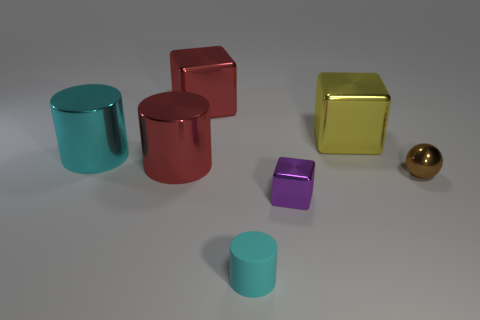How many other objects are there of the same color as the tiny cylinder?
Provide a short and direct response. 1. What material is the cube that is both in front of the large red metal cube and behind the tiny metal block?
Offer a very short reply. Metal. There is a red cylinder; what number of red objects are to the right of it?
Your answer should be very brief. 1. How many cyan metallic spheres are there?
Provide a short and direct response. 0. Do the cyan metal cylinder and the brown shiny thing have the same size?
Your answer should be very brief. No. There is a small ball right of the big block that is right of the tiny cylinder; are there any big cyan objects that are on the left side of it?
Ensure brevity in your answer.  Yes. There is a red object that is the same shape as the small cyan rubber thing; what material is it?
Give a very brief answer. Metal. The shiny block in front of the large cyan cylinder is what color?
Your answer should be compact. Purple. How big is the red cylinder?
Ensure brevity in your answer.  Large. There is a purple object; does it have the same size as the shiny cylinder right of the large cyan metal cylinder?
Offer a terse response. No. 